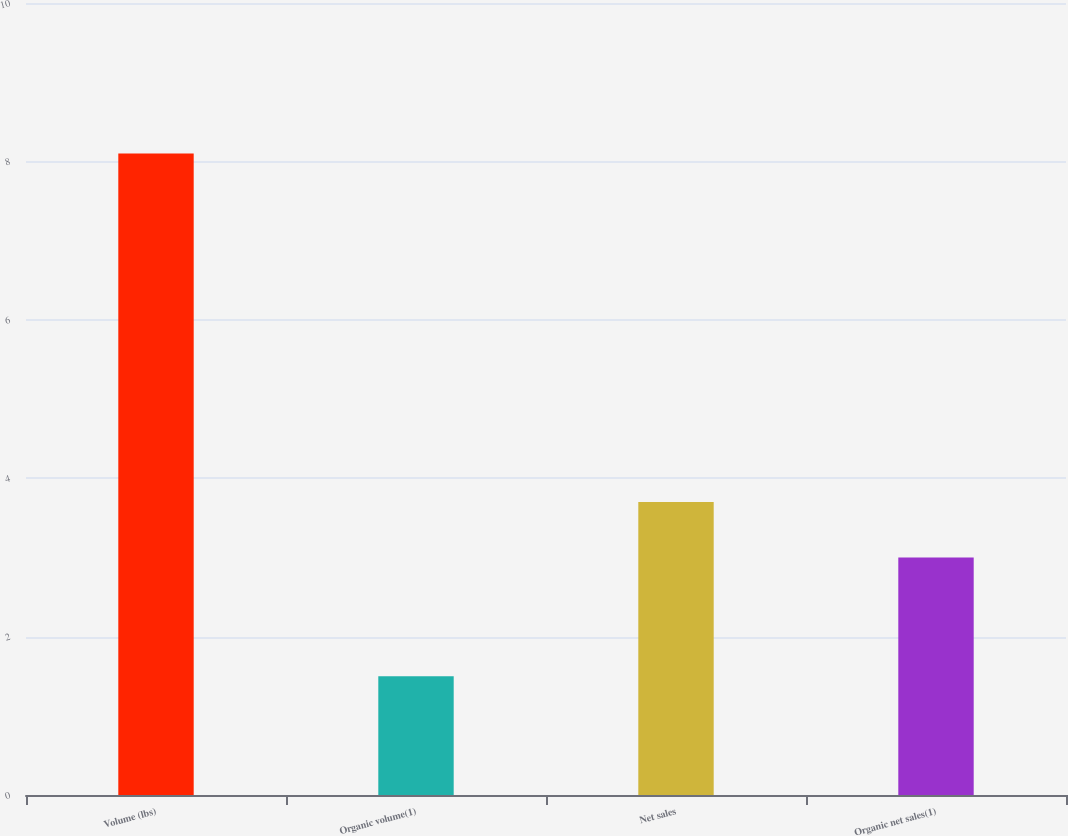Convert chart to OTSL. <chart><loc_0><loc_0><loc_500><loc_500><bar_chart><fcel>Volume (lbs)<fcel>Organic volume(1)<fcel>Net sales<fcel>Organic net sales(1)<nl><fcel>8.1<fcel>1.5<fcel>3.7<fcel>3<nl></chart> 